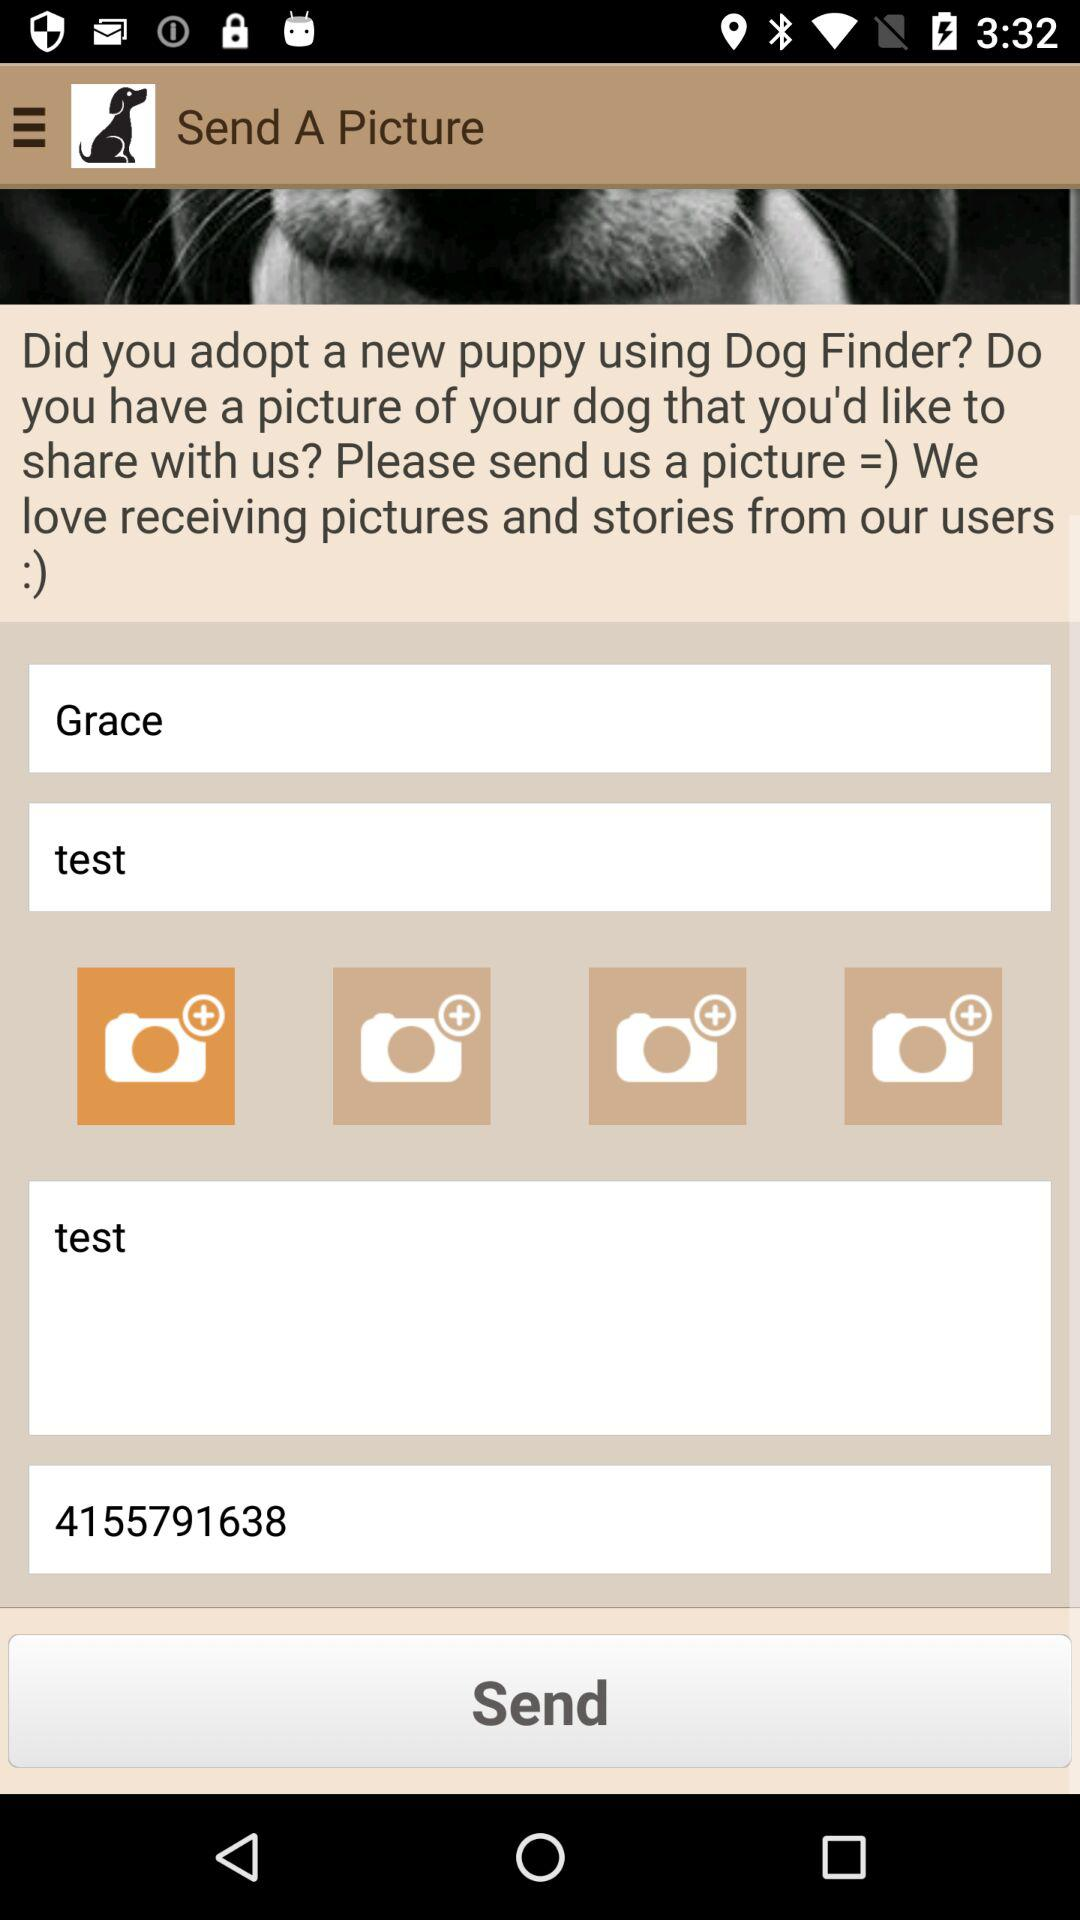What is the entered name? The entered name is Grace. 